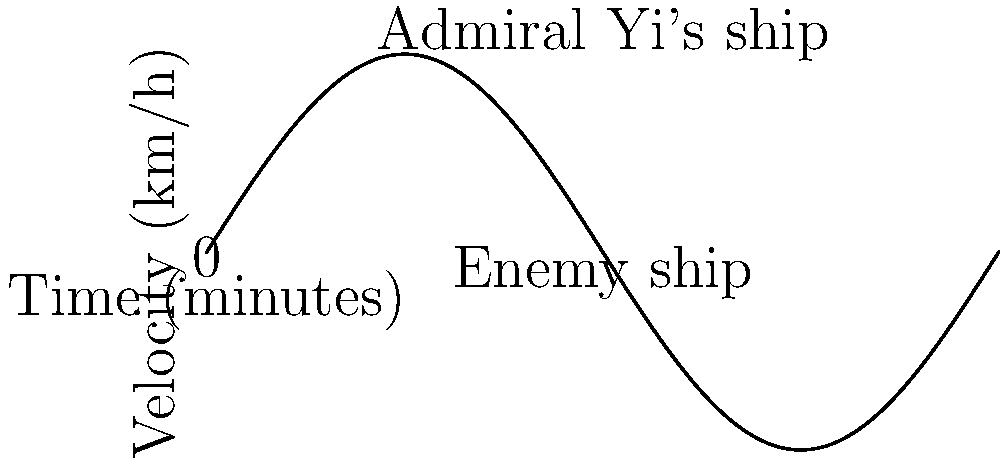In the naval battle of Noryang, Admiral Yi Sun-sin's ship and an enemy vessel are moving along the same path. The velocity-time graph shows their movements over a 2-hour period. If the ships start 10 km apart with Admiral Yi's ship behind, at what time (in minutes) do the ships meet? To solve this problem, we need to follow these steps:

1) The velocity function for Admiral Yi's ship is given by:
   $$v(t) = 30 \sin(\frac{\pi t}{60})$$ km/h, where t is in minutes.

2) To find the position, we need to integrate the velocity function:
   $$s(t) = \int_0^t v(t) dt = \int_0^t 30 \sin(\frac{\pi t}{60}) dt$$

3) Integrating this function:
   $$s(t) = -\frac{1800}{\pi} \cos(\frac{\pi t}{60}) + C$$

4) At t = 0, s = 0, so C = 1800/π. The position function is:
   $$s(t) = \frac{1800}{\pi} (1 - \cos(\frac{\pi t}{60}))$$ km

5) For the enemy ship, the velocity is constant at 0 km/h, so its position is always 10 km ahead of the starting point.

6) The ships meet when their positions are equal:
   $$\frac{1800}{\pi} (1 - \cos(\frac{\pi t}{60})) = 10$$

7) Solving this equation:
   $$\cos(\frac{\pi t}{60}) = 1 - \frac{10\pi}{1800} \approx 0.9826$$
   $$\frac{\pi t}{60} = \arccos(0.9826) \approx 0.1866$$
   $$t \approx 3.56 \text{ minutes}$$

Therefore, the ships meet approximately 3.56 minutes into the battle.
Answer: 3.56 minutes 